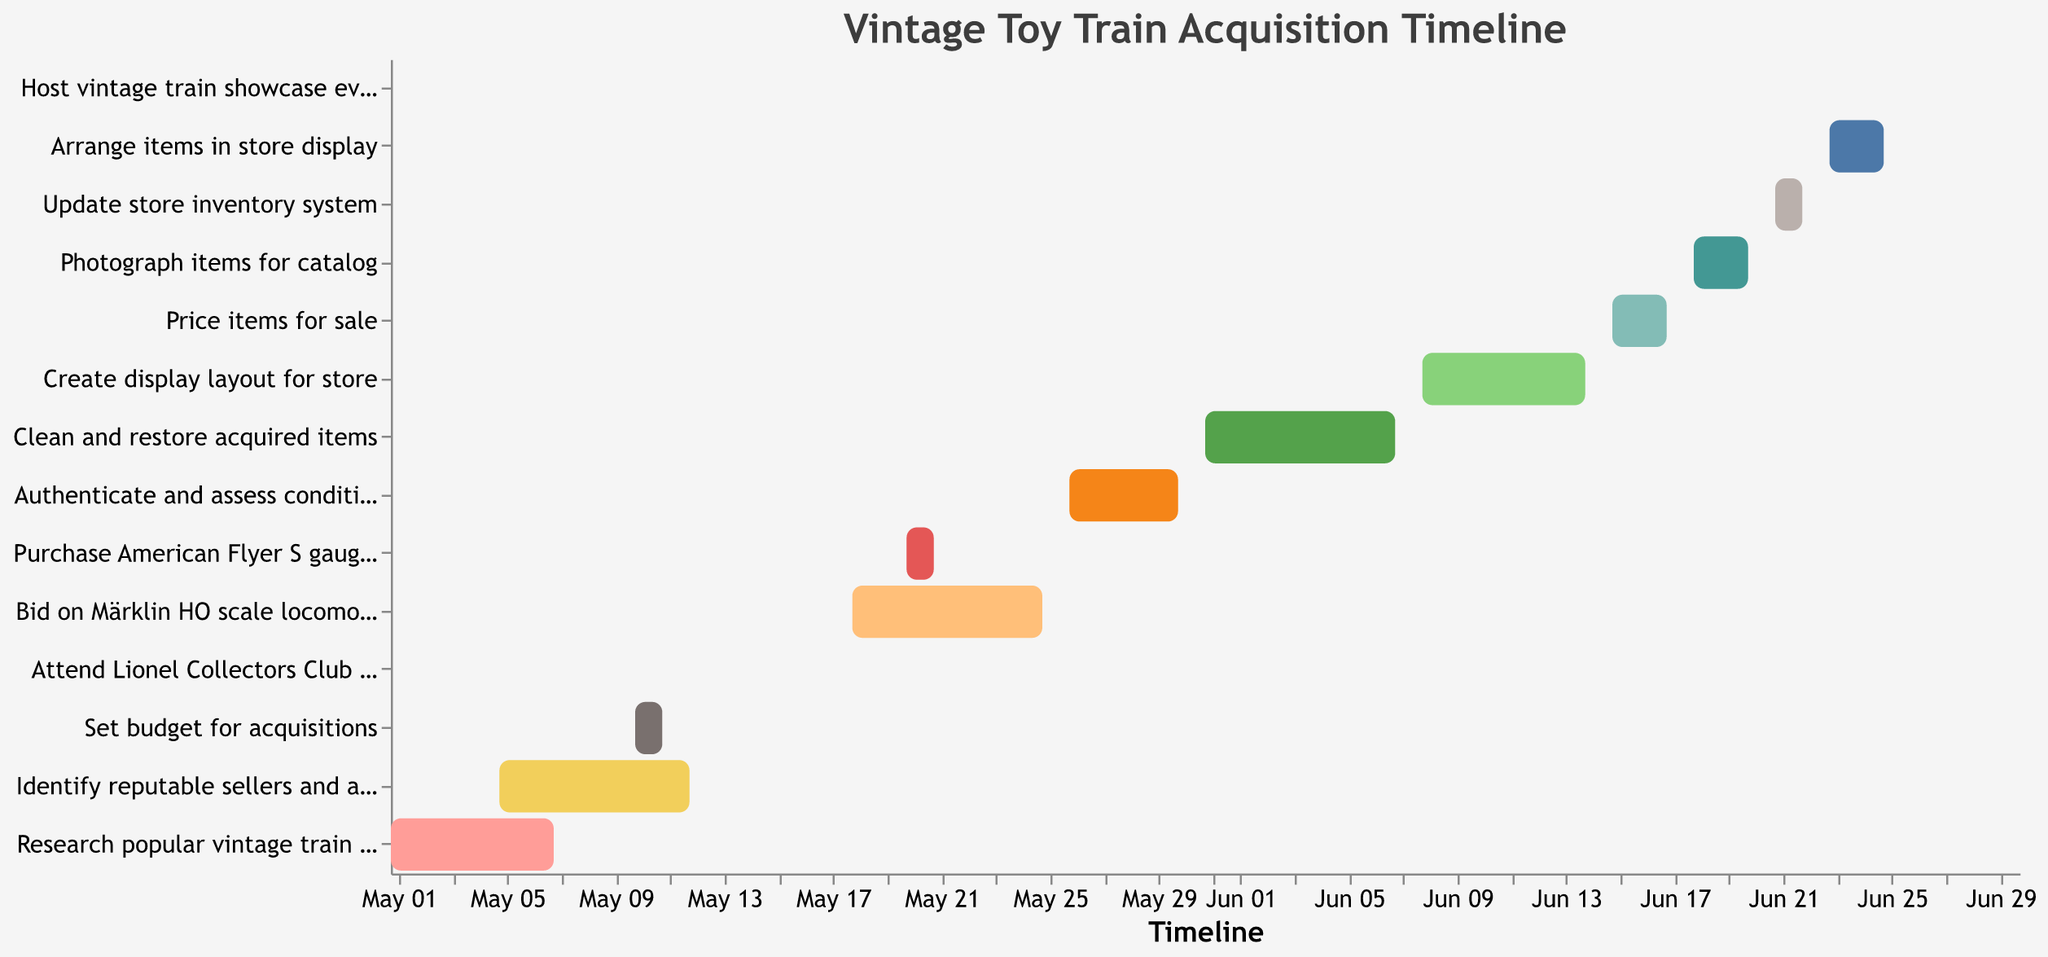Which task starts on May 10? By looking at the Gantt chart, we find the task that corresponds to the Start Date of May 10, which is "Set budget for acquisitions".
Answer: Set budget for acquisitions When does the task "Clean and restore acquired items" end? In the Gantt chart, "Clean and restore acquired items" starts on May 31 and ends on June 7.
Answer: June 7 Which two tasks overlap between May 10 and May 12? We need to find tasks starting or ending between May 10 and May 12. "Identify reputable sellers and auctions" (May 5–May 12) and "Set budget for acquisitions" (May 10–May 11) overlap in this period.
Answer: Identify reputable sellers and auctions & Set budget for acquisitions How long is the "Clean and restore acquired items" process? "Clean and restore acquired items" starts on May 31 and ends on June 7. By counting the days including both start and end date, we get 8 days.
Answer: 8 days What is the last task on the timeline? The last task listed in the Gantt Chart is "Host vintage train showcase event", which is a one-day event on June 30.
Answer: Host vintage train showcase event Compare the lengths of time for "Bid on Märklin HO scale locomotive" and "Purchase American Flyer S gauge set". Which one is longer? "Bid on Märklin HO scale locomotive" runs from May 18 to May 25, lasting 8 days. "Purchase American Flyer S gauge set" runs from May 20 to May 21, lasting 2 days. By comparison, "Bid on Märklin HO scale locomotive" is longer.
Answer: Bid on Märklin HO scale locomotive How many tasks overlap with "Create display layout for store"? "Create display layout for store" runs from June 8 to June 14. Tasks that overlap are: "Clean and restore acquired items" (until June 7) and "Price items for sale" (starting June 15). No tasks overlap directly within the June 8–June 14 range.
Answer: 0 What tasks begin after June 20? Scanning the timeline for tasks beginning after June 20, we find "Update store inventory system" (June 21), "Arrange items in store display" (June 23), and "Host vintage train showcase event" (June 30).
Answer: Update store inventory system, Arrange items in store display, Host vintage train showcase event Which task has the shortest duration? By comparing the durations of each task, "Attend Lionel Collectors Club meeting" starts and ends on the same day, May 15, making it the shortest duration at 1 day.
Answer: Attend Lionel Collectors Club meeting What is the time range between the start of the first task and the end of the last task? The first task "Research popular vintage train models" starts on May 1 and the last task "Host vintage train showcase event" ends on June 30. The time range is May 1 to June 30, covering 61 days.
Answer: 61 days 